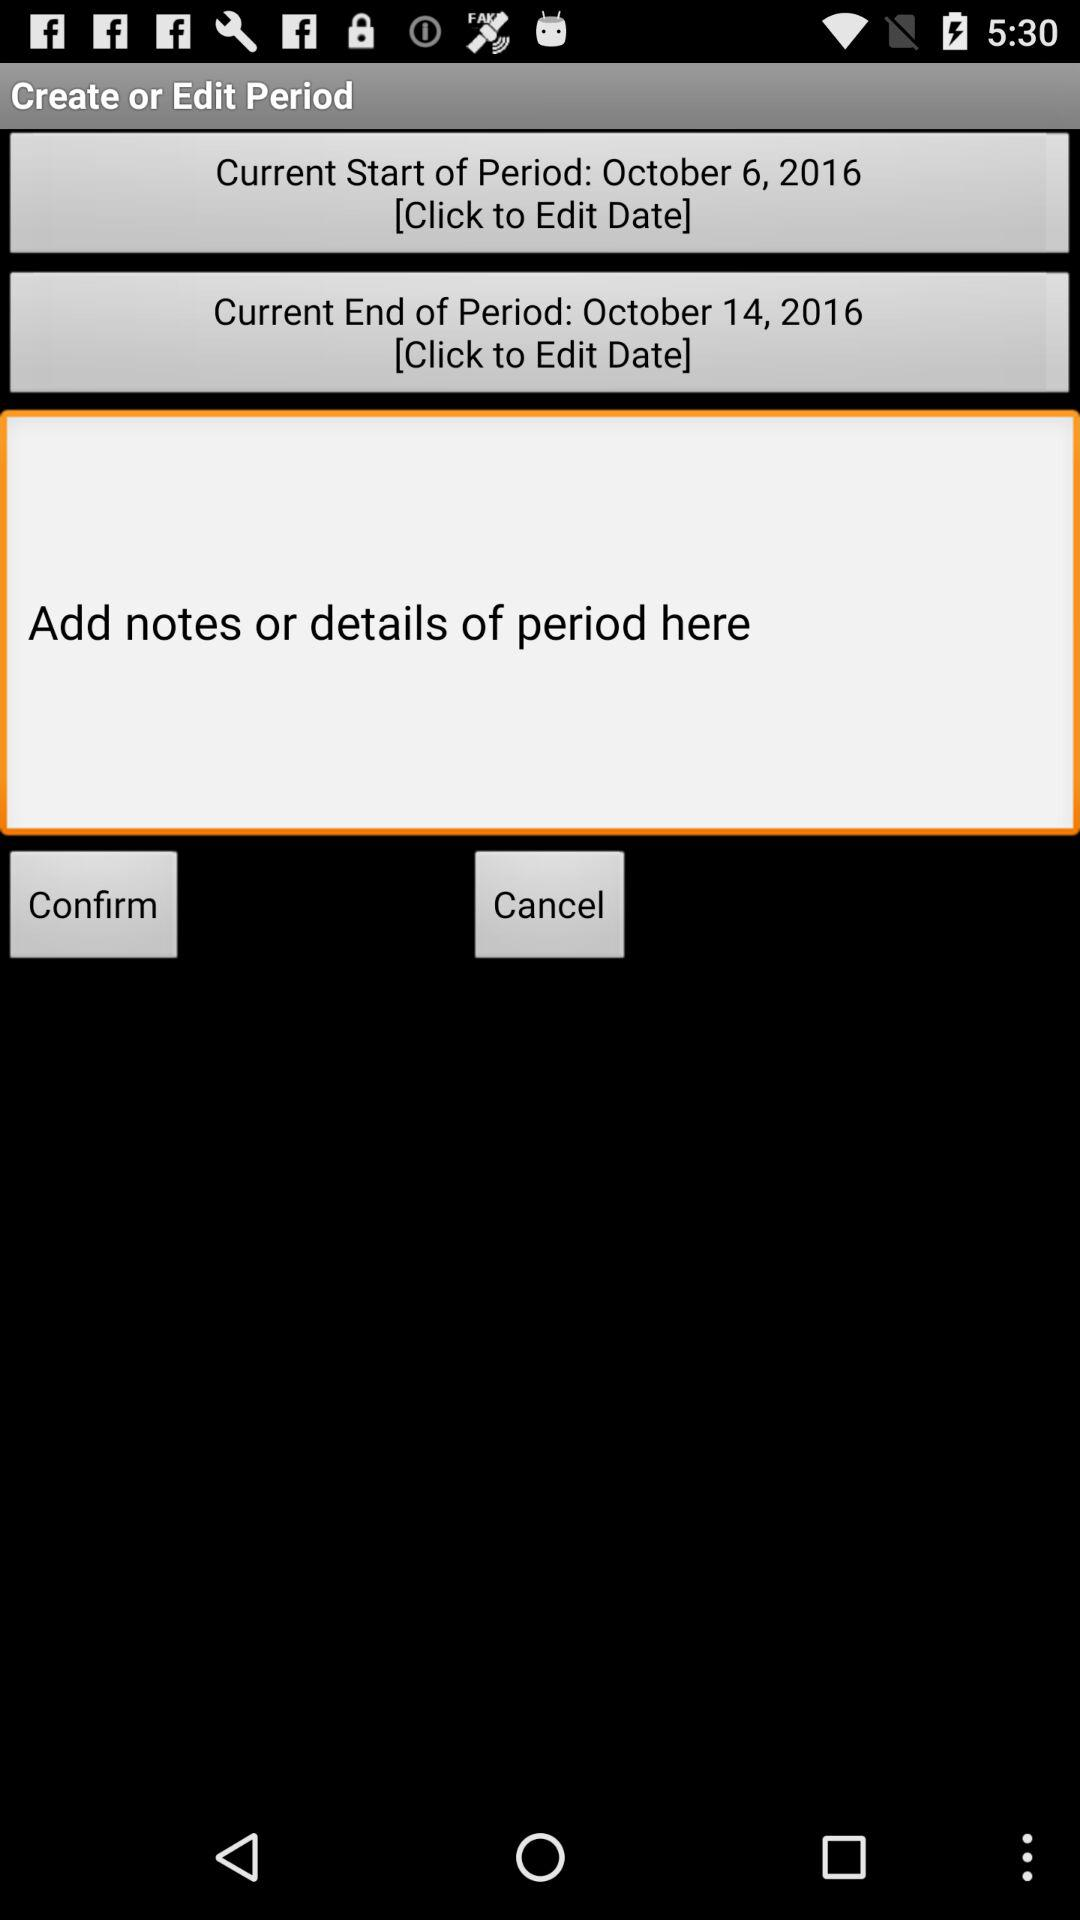What is the "Current End of Period" date? The date is October 14, 2016. 